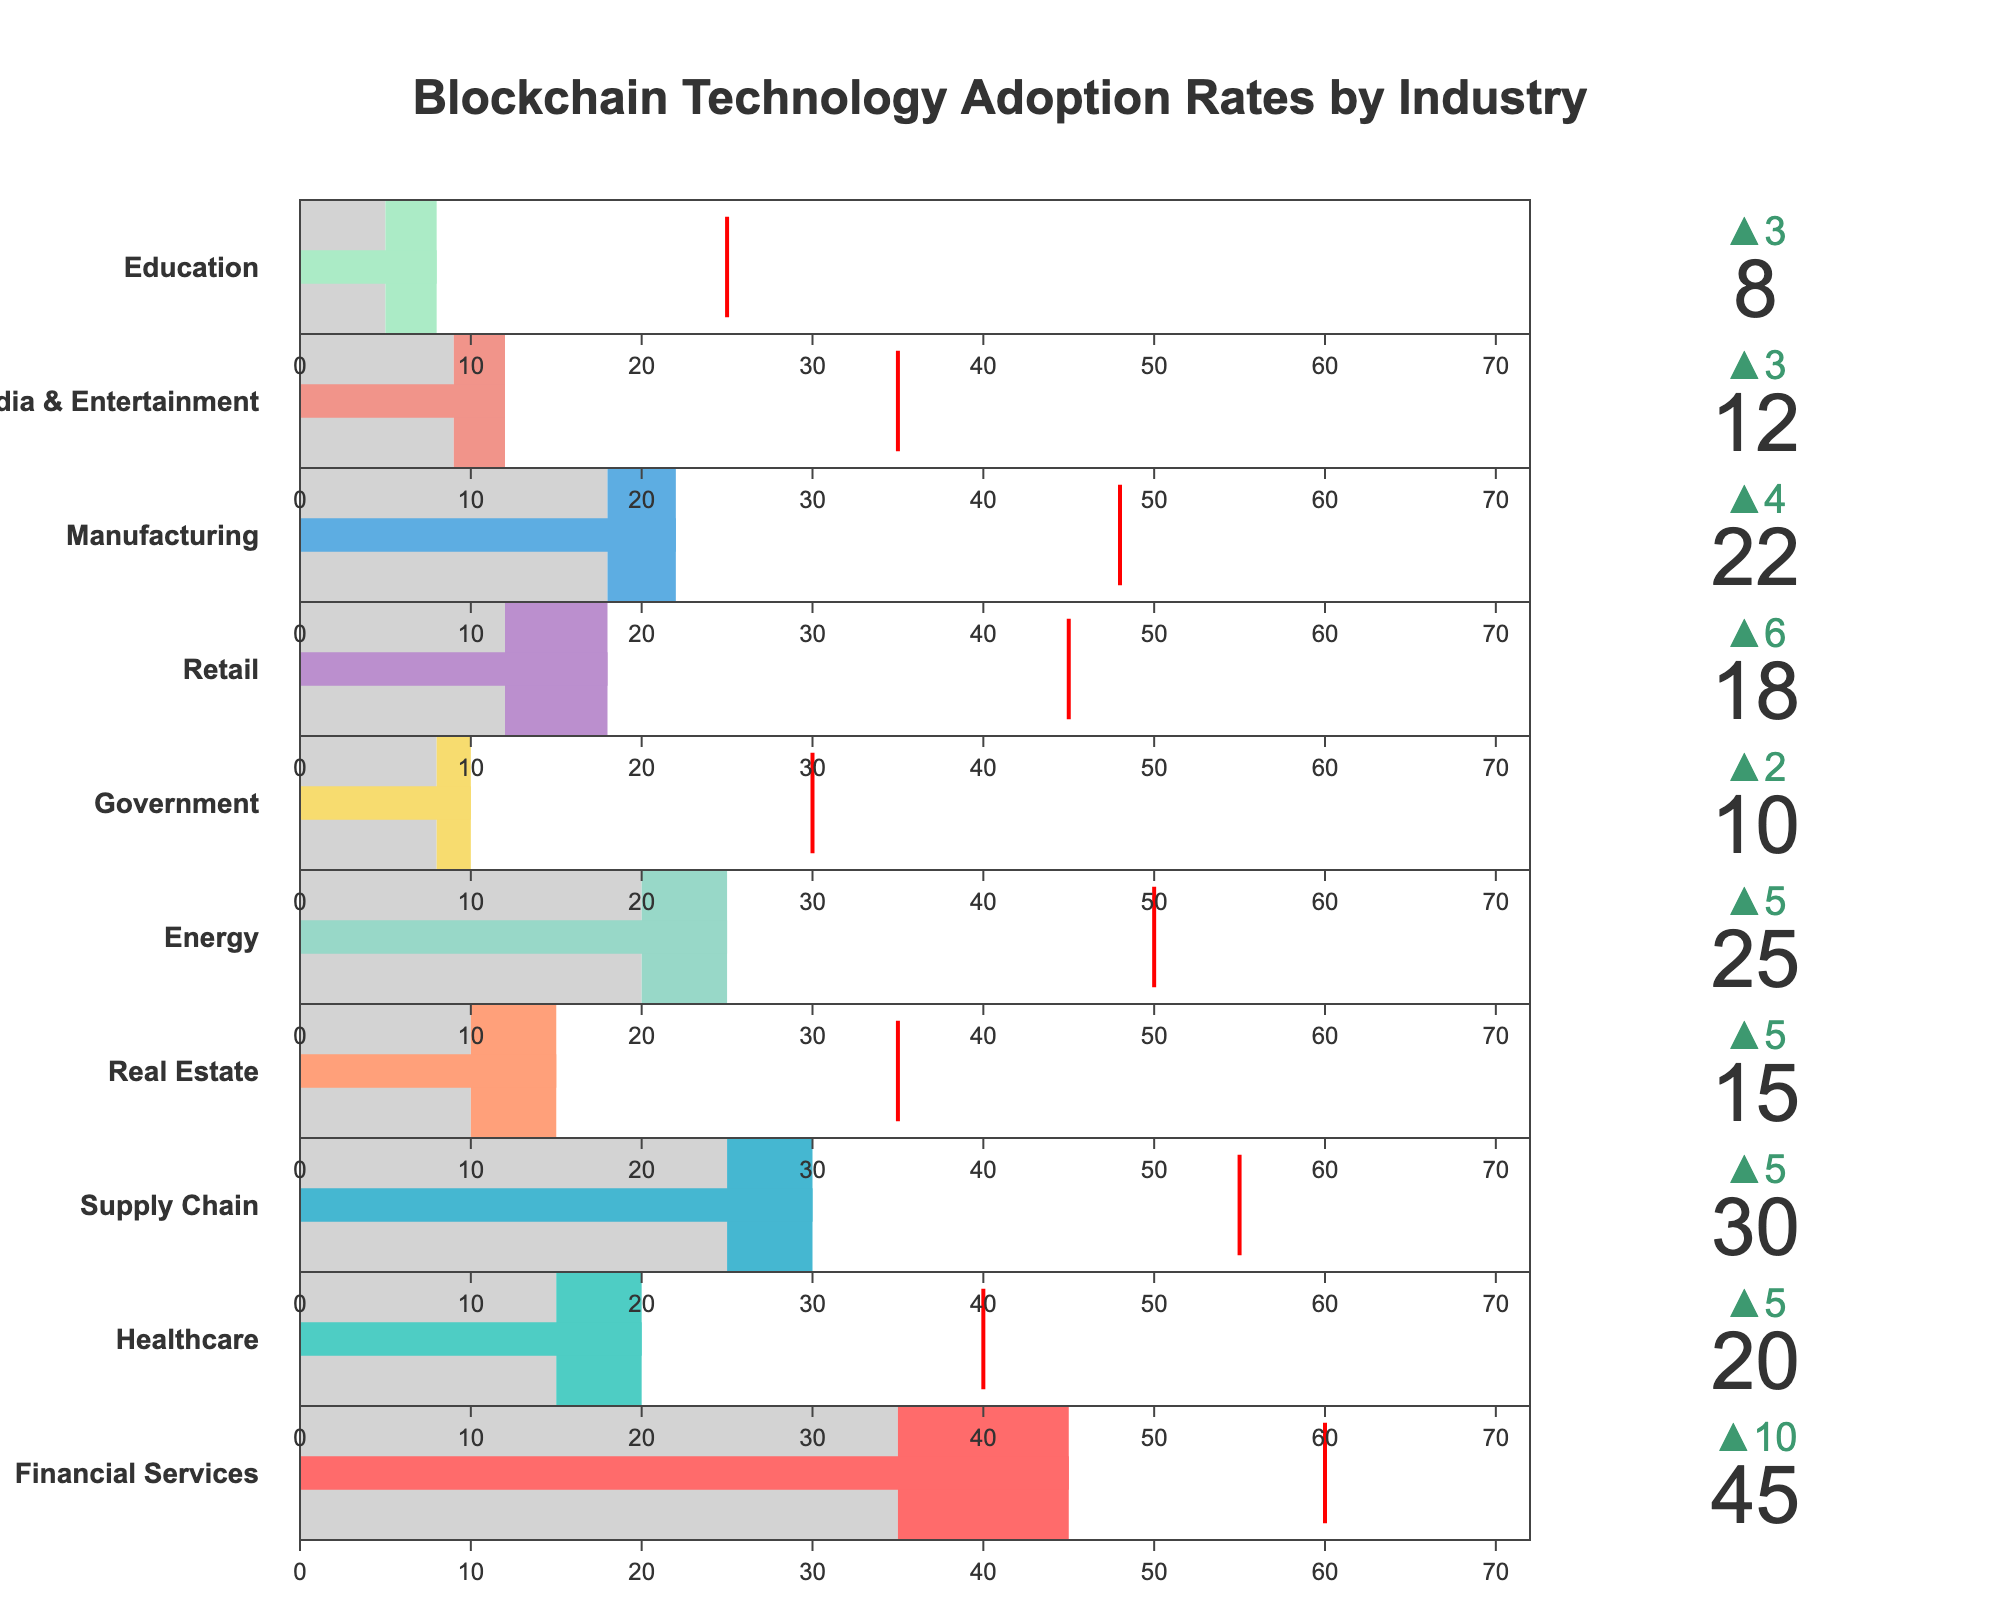How many industries are presented in the figure? There are 10 different industries listed in the data, each with their own section in the bullet chart.
Answer: 10 What is the title of the figure? The title is located at the top center of the figure.
Answer: Blockchain Technology Adoption Rates by Industry Which industry has the highest current adoption rate of blockchain technology? The current adoption rates are shown as the main bar within each bullet chart. The highest value is found in the Financial Services industry.
Answer: Financial Services By how much does the current adoption rate in Healthcare exceed the industry average? Locate the Healthcare section. The current adoption rate is 20%, and the industry average is 15%. Subtract the industry average from the current adoption.
Answer: 5% In which industry is the target adoption rate exactly twice the current adoption rate? Compare the current and target adoption rates. In Healthcare, the target adoption (40%) is exactly twice the current adoption (20%).
Answer: Healthcare Which industry has the smallest difference between current adoption and the target adoption rate? Calculate the differences between target and current adoption for all industries. The smallest difference is in Financial Services (60% - 45% = 15%).
Answer: Financial Services What colors are used to represent the steps in the bullet chart for the Real Estate industry? Examine the Real Estate section. It uses light gray for the range up to the industry average and another color (salmon like) for the range until current adoption.
Answer: Light gray and salmon-like Which industries have current adoption rates that are less than the industry average? Compare all current adoption rates to the corresponding industry averages. None of the industries shown have current adoption rates less than their industry average.
Answer: None How does the current adoption rate in the Energy sector compare to that in Manufacturing? The bar for current adoption rates shows that Energy has 25% while Manufacturing has 22%.
Answer: Energy is higher What is the projection for blockchain adoption in the Retail industry compared to its current adoption? Observe the target adoption and current adoption in the Retail section. The target (45%) is much higher than the current (18%).
Answer: Target is 45%, current is 18% 